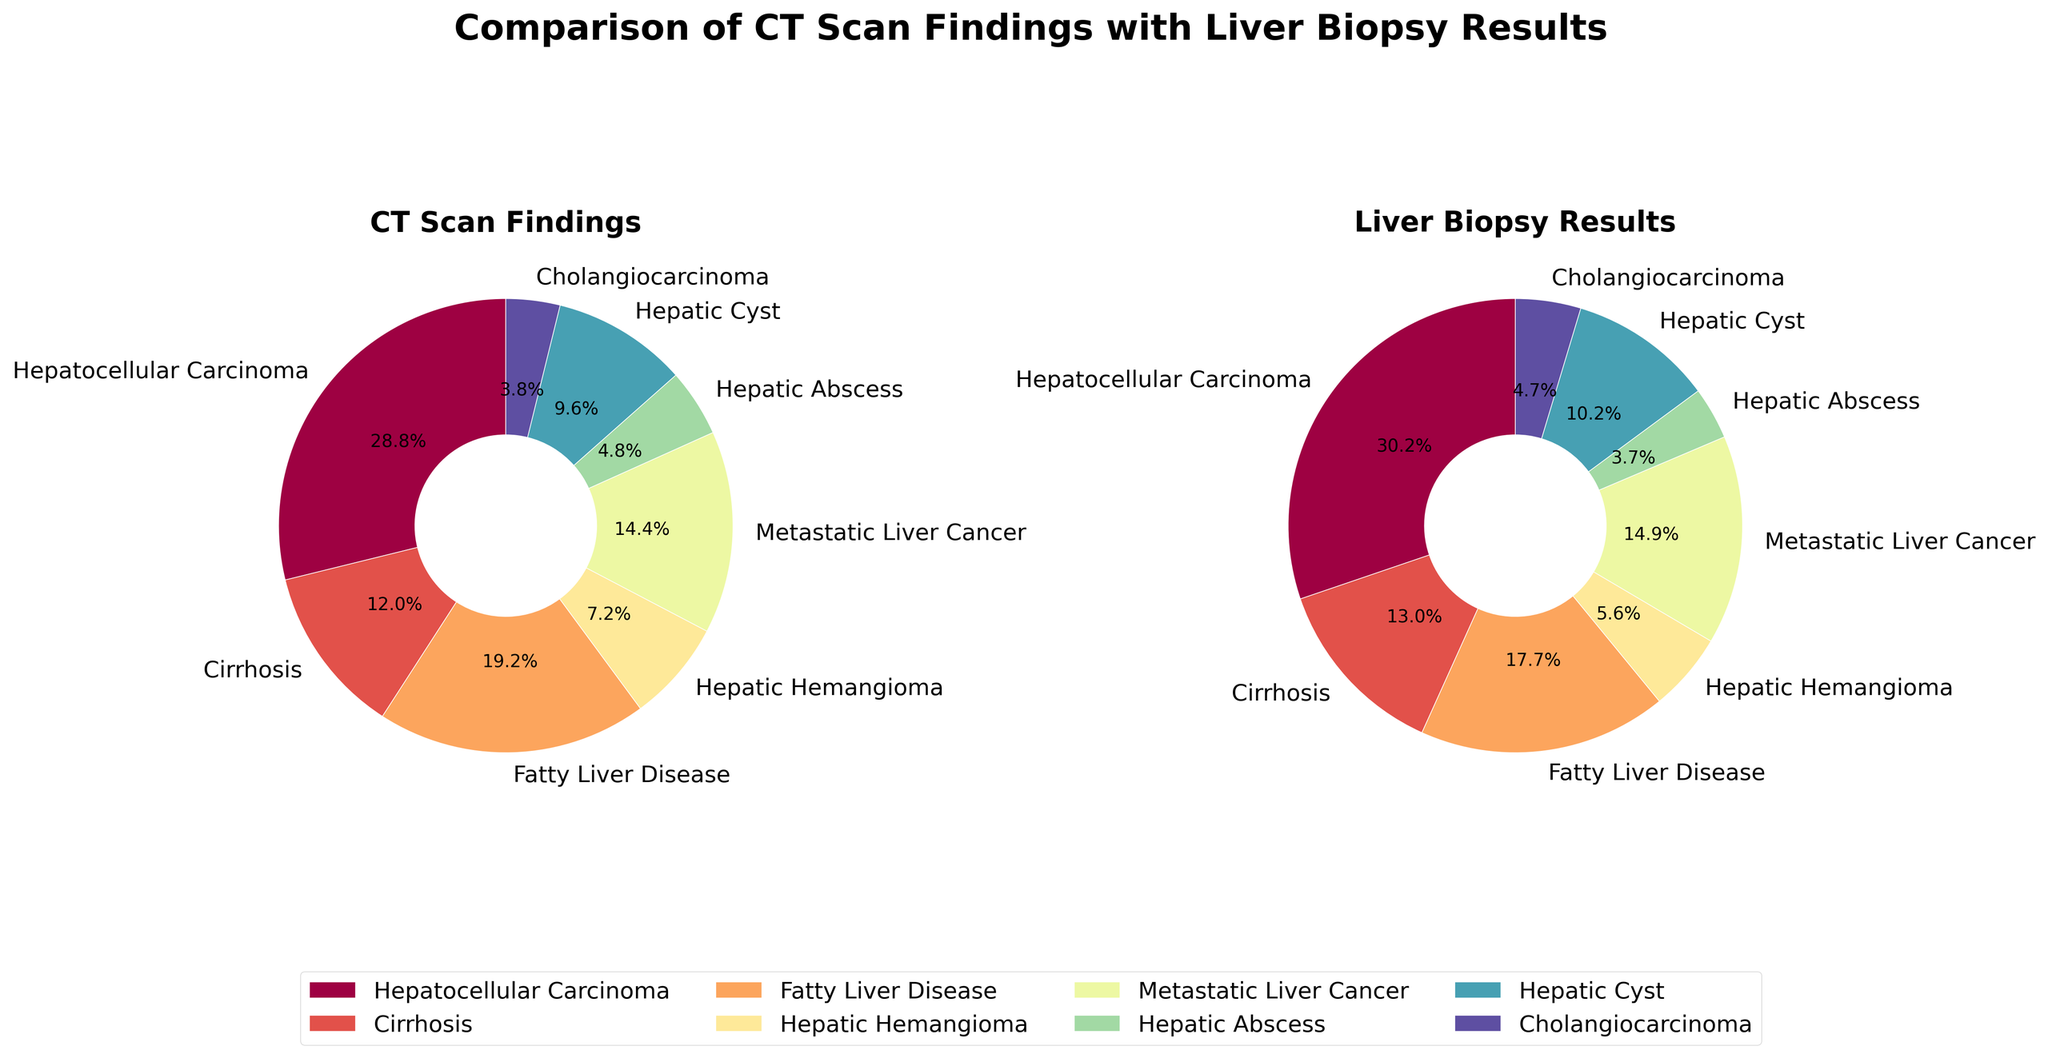What is the title of the figure? The title of the figure can be found at the top of the subplot. It reads "Comparison of CT Scan Findings with Liver Biopsy Results", which indicates the overall subject of the data presented.
Answer: Comparison of CT Scan Findings with Liver Biopsy Results Which disease has the highest percentage in the CT scan findings? To find the disease with the highest percentage, look at the pie chart on the left labeled "CT Scan Findings". The "Hepatocellular Carcinoma" segment seems to have the largest slice, which is confirmed by the percentage label showing 60%.
Answer: Hepatocellular Carcinoma What percentage of diseases were identified as Cirrhosis in the biopsy results? In the pie chart on the right labeled "Liver Biopsy Results", find the segment labeled "Cirrhosis" and read the percentage label next to it. The label shows 11.85% (rounded to 12%).
Answer: 12% Compare the CT scan findings and biopsy results for Hepatic Cyst. Which method identified a higher percentage and by how much? On the left pie chart, "CT Scan Findings", the label for "Hepatic Cyst" is 6.8%. On the right pie chart, "Liver Biopsy Results", the label for "Hepatic Cyst" is 8.5%. Subtract these percentages to find the difference. 8.5% - 6.8% = 1.7%. Therefore, biopsy results identified a higher percentage by 1.7%.
Answer: Biopsy results by 1.7% Which disease shows the closest matching percentage in both CT scan findings and biopsy results? To determine this, compare the percentage labels on both pie charts for each disease. "Fatty Liver Disease" shows 29.6% in CT findings and 28.8% in biopsy results. The difference is 0.8%, which is the closest match among all diseases.
Answer: Fatty Liver Disease What is the combined percentage of "Hepatic Hemangioma" and "Hepatic Abscess" in the biopsy results? First look at the right pie chart, labeled "Liver Biopsy Results". "Hepatic Hemangioma" is at 5.9% and "Hepatic Abscess" is at 3.9%. Add these two percentages: 5.9% + 3.9% = 9.8%.
Answer: 9.8% What is the difference in percentage between Cirrhosis and Fatty Liver Disease in the CT scan findings? In the left pie chart labeled "CT Scan Findings", find the percentages for "Cirrhosis" (which is 18.5%) and "Fatty Liver Disease" (which is 29.6%). Subtract these to get the difference: 29.6% - 18.5% = 11.1%.
Answer: 11.1% What is the total percentage identified by CT scan findings for Metastatic Liver Cancer and Cholangiocarcinoma combined? Look at the left pie chart labeled "CT Scan Findings". The percentage for "Metastatic Liver Cancer" is 22.2% and for "Cholangiocarcinoma" is 5.9%. Add these two percentages together: 22.2% + 5.9% = 28.1%.
Answer: 28.1% 